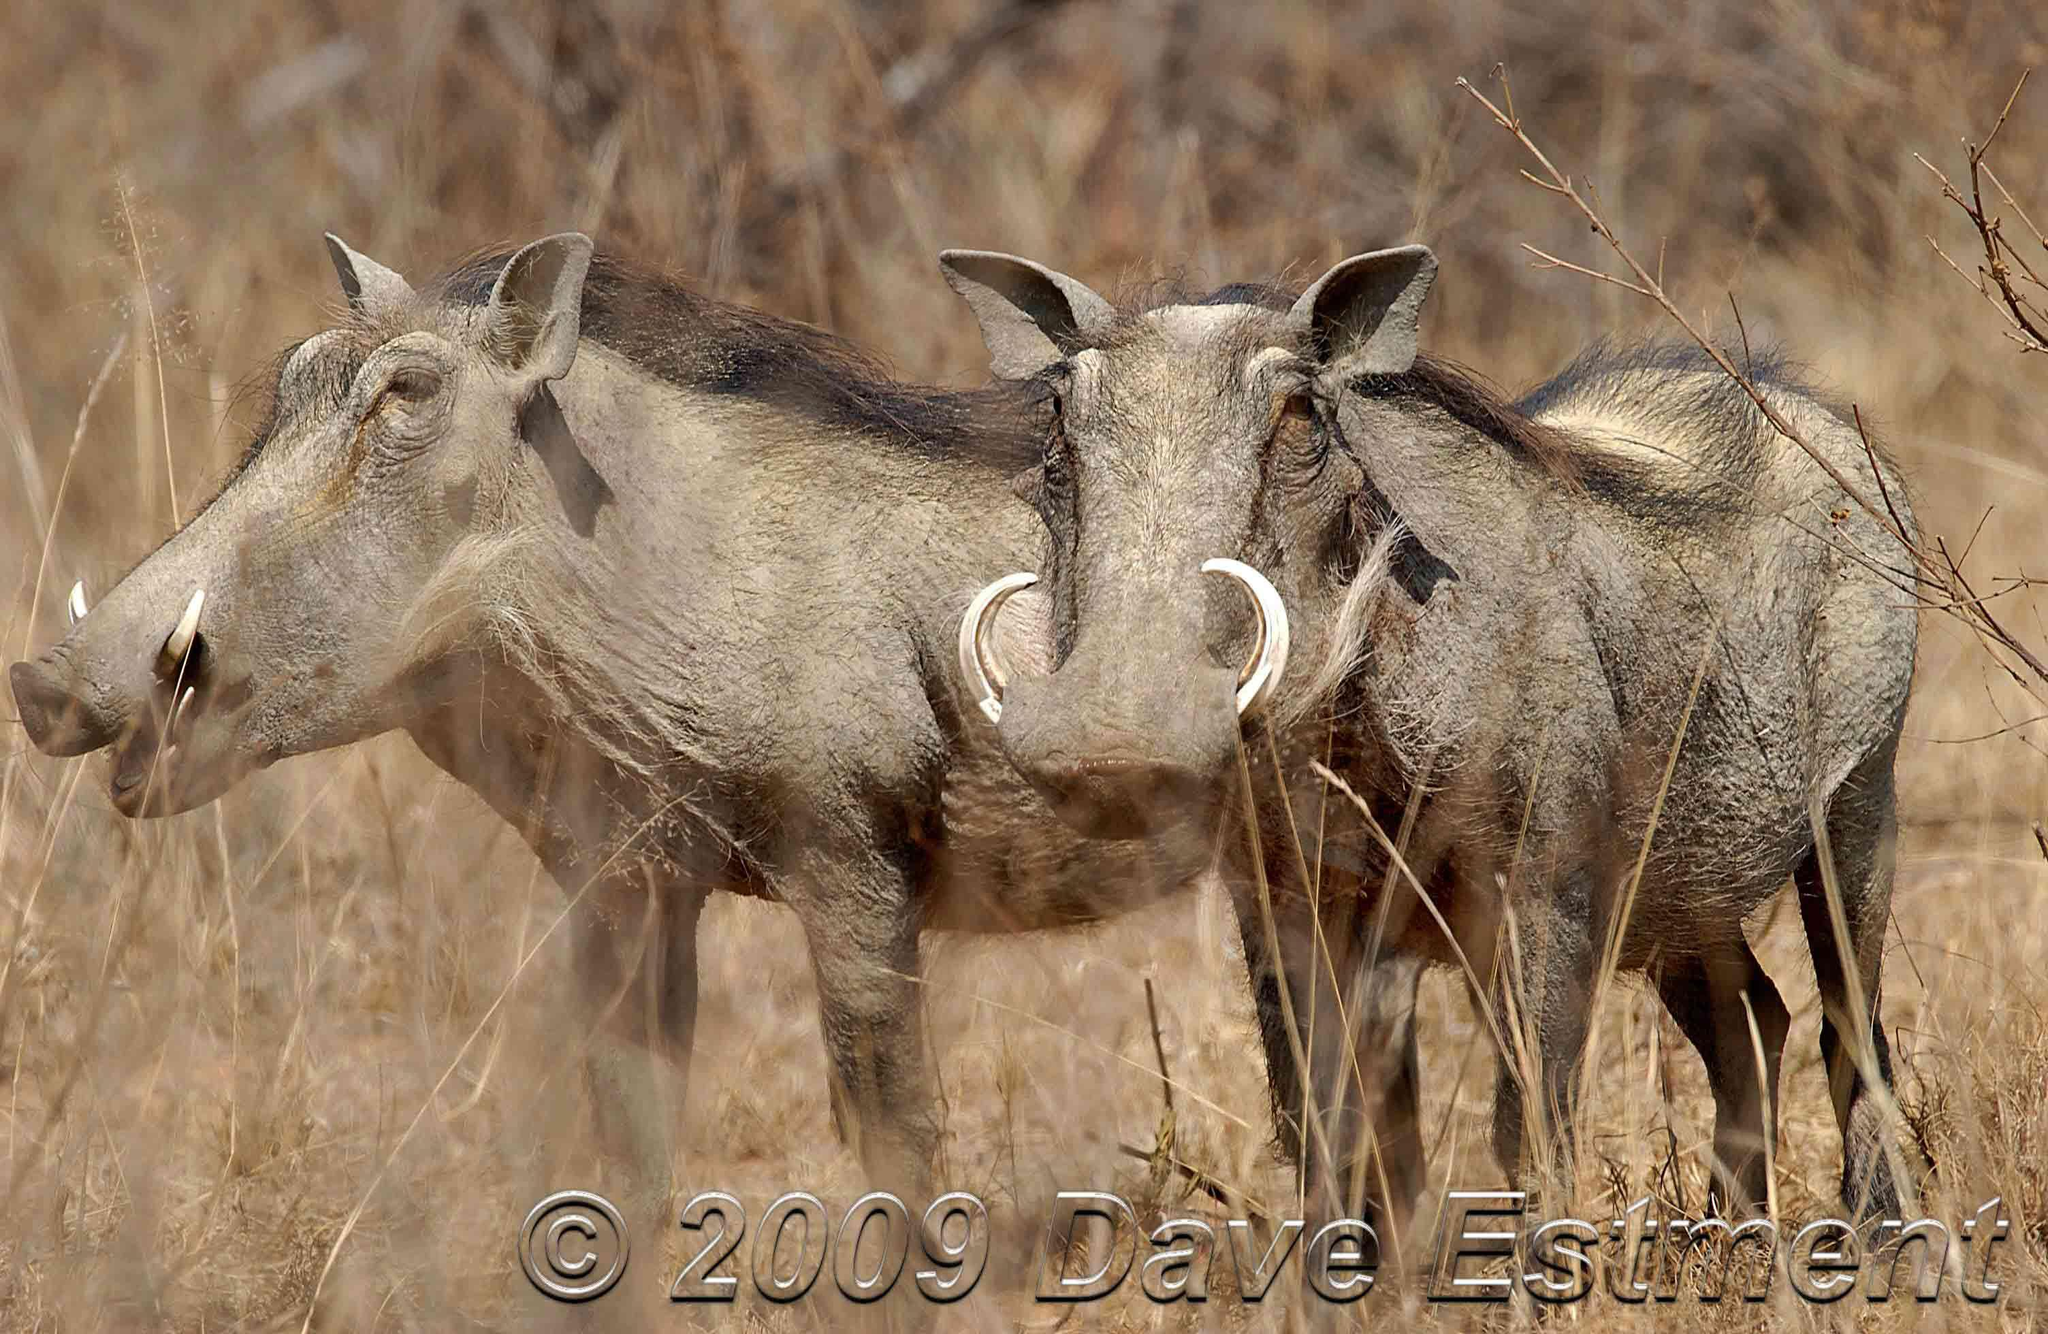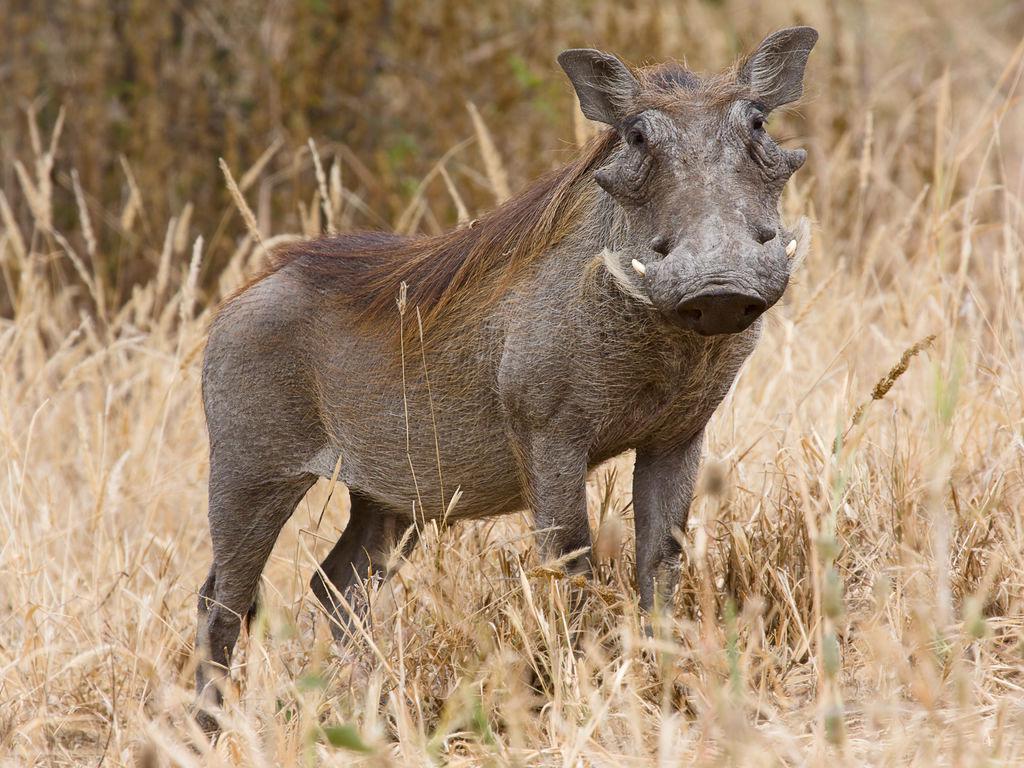The first image is the image on the left, the second image is the image on the right. For the images displayed, is the sentence "One image shows exactly one pair of similarly-posed warthogs in a mostly brown scene." factually correct? Answer yes or no. Yes. The first image is the image on the left, the second image is the image on the right. For the images shown, is this caption "The right image contains exactly two warthogs." true? Answer yes or no. No. 